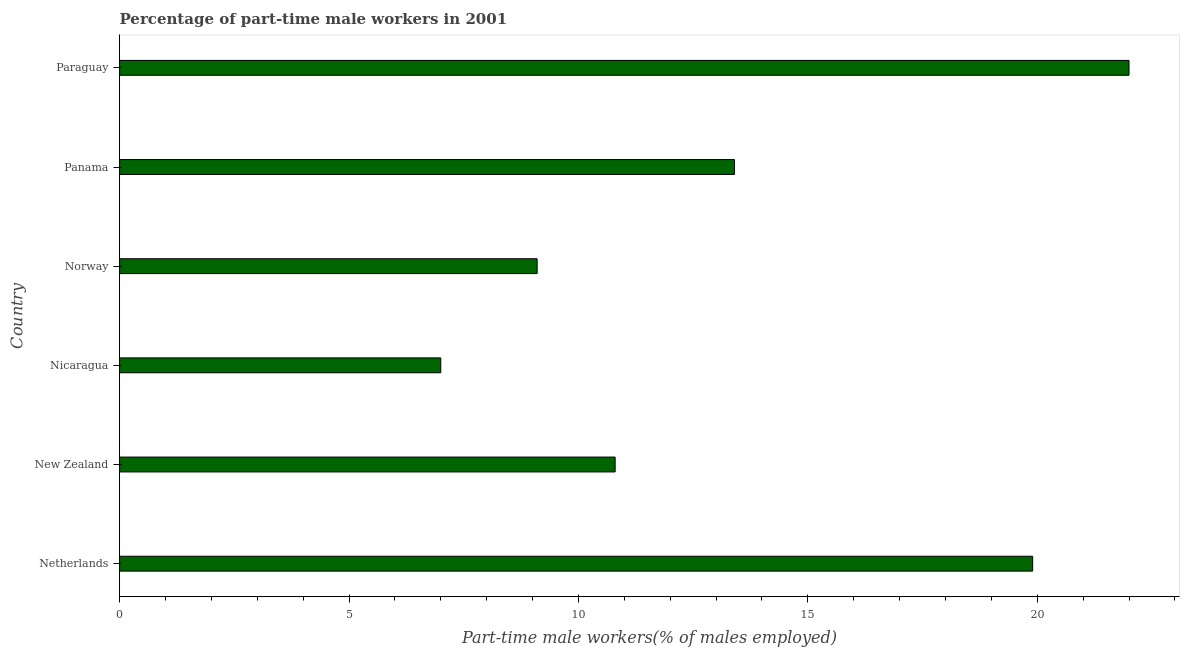What is the title of the graph?
Offer a terse response. Percentage of part-time male workers in 2001. What is the label or title of the X-axis?
Your answer should be compact. Part-time male workers(% of males employed). What is the percentage of part-time male workers in Netherlands?
Offer a terse response. 19.9. Across all countries, what is the maximum percentage of part-time male workers?
Offer a terse response. 22. Across all countries, what is the minimum percentage of part-time male workers?
Ensure brevity in your answer.  7. In which country was the percentage of part-time male workers maximum?
Give a very brief answer. Paraguay. In which country was the percentage of part-time male workers minimum?
Make the answer very short. Nicaragua. What is the sum of the percentage of part-time male workers?
Ensure brevity in your answer.  82.2. What is the difference between the percentage of part-time male workers in New Zealand and Nicaragua?
Give a very brief answer. 3.8. What is the average percentage of part-time male workers per country?
Offer a terse response. 13.7. What is the median percentage of part-time male workers?
Offer a very short reply. 12.1. What is the ratio of the percentage of part-time male workers in Netherlands to that in Nicaragua?
Provide a succinct answer. 2.84. Is the percentage of part-time male workers in Netherlands less than that in Panama?
Your response must be concise. No. Is the sum of the percentage of part-time male workers in New Zealand and Nicaragua greater than the maximum percentage of part-time male workers across all countries?
Your response must be concise. No. What is the difference between the highest and the lowest percentage of part-time male workers?
Make the answer very short. 15. How many bars are there?
Offer a terse response. 6. How many countries are there in the graph?
Keep it short and to the point. 6. What is the difference between two consecutive major ticks on the X-axis?
Ensure brevity in your answer.  5. Are the values on the major ticks of X-axis written in scientific E-notation?
Give a very brief answer. No. What is the Part-time male workers(% of males employed) of Netherlands?
Your response must be concise. 19.9. What is the Part-time male workers(% of males employed) of New Zealand?
Give a very brief answer. 10.8. What is the Part-time male workers(% of males employed) of Norway?
Provide a short and direct response. 9.1. What is the Part-time male workers(% of males employed) in Panama?
Offer a very short reply. 13.4. What is the Part-time male workers(% of males employed) of Paraguay?
Offer a terse response. 22. What is the difference between the Part-time male workers(% of males employed) in Netherlands and Nicaragua?
Give a very brief answer. 12.9. What is the difference between the Part-time male workers(% of males employed) in Netherlands and Panama?
Your response must be concise. 6.5. What is the difference between the Part-time male workers(% of males employed) in Netherlands and Paraguay?
Give a very brief answer. -2.1. What is the difference between the Part-time male workers(% of males employed) in New Zealand and Norway?
Provide a short and direct response. 1.7. What is the difference between the Part-time male workers(% of males employed) in New Zealand and Paraguay?
Provide a succinct answer. -11.2. What is the difference between the Part-time male workers(% of males employed) in Nicaragua and Panama?
Offer a terse response. -6.4. What is the difference between the Part-time male workers(% of males employed) in Norway and Panama?
Ensure brevity in your answer.  -4.3. What is the ratio of the Part-time male workers(% of males employed) in Netherlands to that in New Zealand?
Your answer should be very brief. 1.84. What is the ratio of the Part-time male workers(% of males employed) in Netherlands to that in Nicaragua?
Offer a terse response. 2.84. What is the ratio of the Part-time male workers(% of males employed) in Netherlands to that in Norway?
Give a very brief answer. 2.19. What is the ratio of the Part-time male workers(% of males employed) in Netherlands to that in Panama?
Keep it short and to the point. 1.49. What is the ratio of the Part-time male workers(% of males employed) in Netherlands to that in Paraguay?
Your answer should be very brief. 0.91. What is the ratio of the Part-time male workers(% of males employed) in New Zealand to that in Nicaragua?
Provide a short and direct response. 1.54. What is the ratio of the Part-time male workers(% of males employed) in New Zealand to that in Norway?
Your answer should be compact. 1.19. What is the ratio of the Part-time male workers(% of males employed) in New Zealand to that in Panama?
Offer a very short reply. 0.81. What is the ratio of the Part-time male workers(% of males employed) in New Zealand to that in Paraguay?
Provide a succinct answer. 0.49. What is the ratio of the Part-time male workers(% of males employed) in Nicaragua to that in Norway?
Offer a very short reply. 0.77. What is the ratio of the Part-time male workers(% of males employed) in Nicaragua to that in Panama?
Ensure brevity in your answer.  0.52. What is the ratio of the Part-time male workers(% of males employed) in Nicaragua to that in Paraguay?
Give a very brief answer. 0.32. What is the ratio of the Part-time male workers(% of males employed) in Norway to that in Panama?
Offer a terse response. 0.68. What is the ratio of the Part-time male workers(% of males employed) in Norway to that in Paraguay?
Provide a succinct answer. 0.41. What is the ratio of the Part-time male workers(% of males employed) in Panama to that in Paraguay?
Make the answer very short. 0.61. 